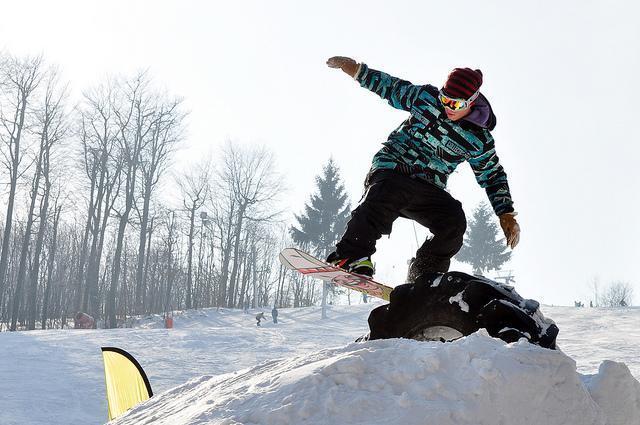How many orange fruits are there?
Give a very brief answer. 0. 